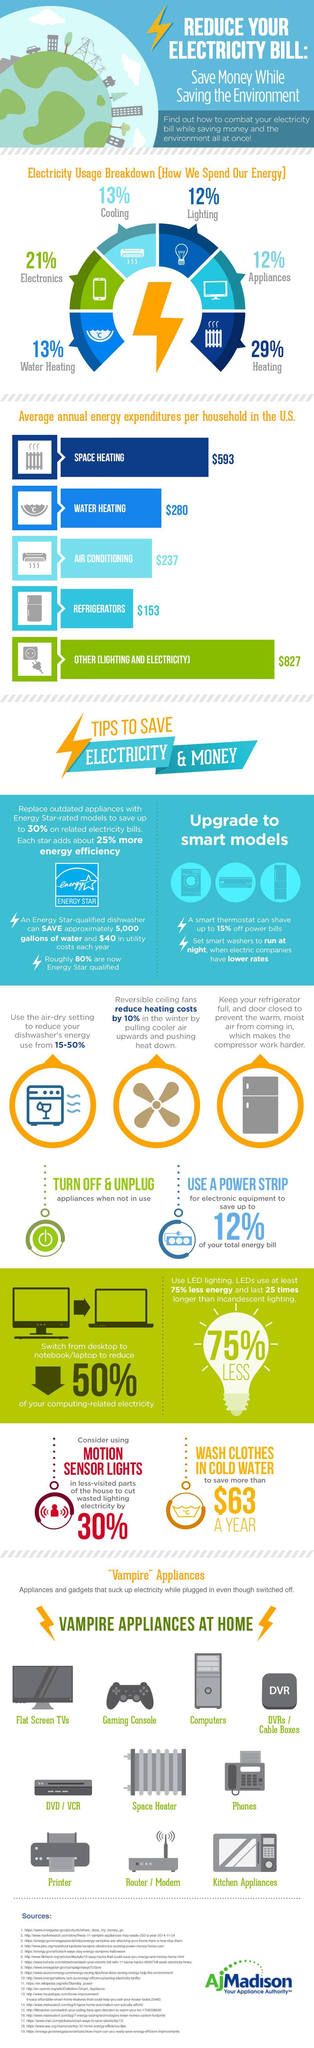Which appliance uses  a major chunk of energy produced in percentage, Heating appliances, Electronic devices, or Lighting devices?
Answer the question with a short phrase. Heating Appliances What would be expenditure incurred by a Household in dollars, if they had a well lit home with a refrigerator and water heater? $1,260 How many appliances suck up electricity even when not plugged in? 9 What is the percentage of electricity used by cooling and water heating appliances? 13% 